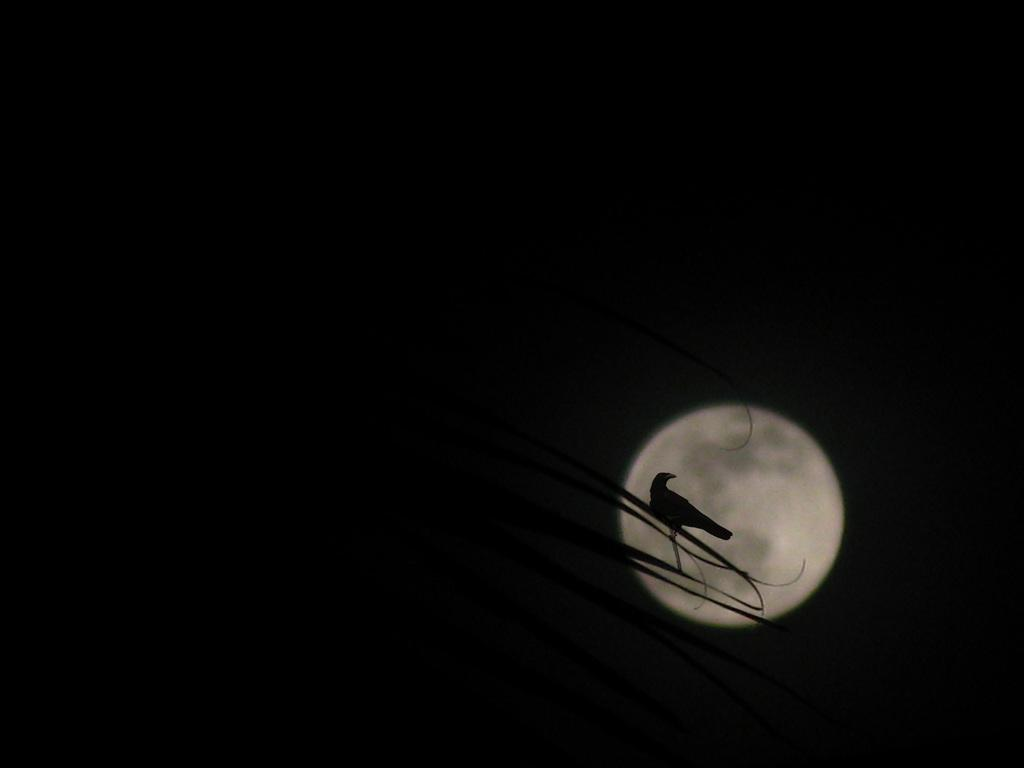What type of animal can be seen in the image? There is a bird in the image. Where is the bird located? The bird is on the leaves. What celestial body is visible in the image? The moon is visible in the image. How would you describe the color of the sky in the image? The sky is dark in the image. What type of pollution can be seen in the image? There is no pollution visible in the image. Is there a plough present in the image? There is no plough present in the image. 